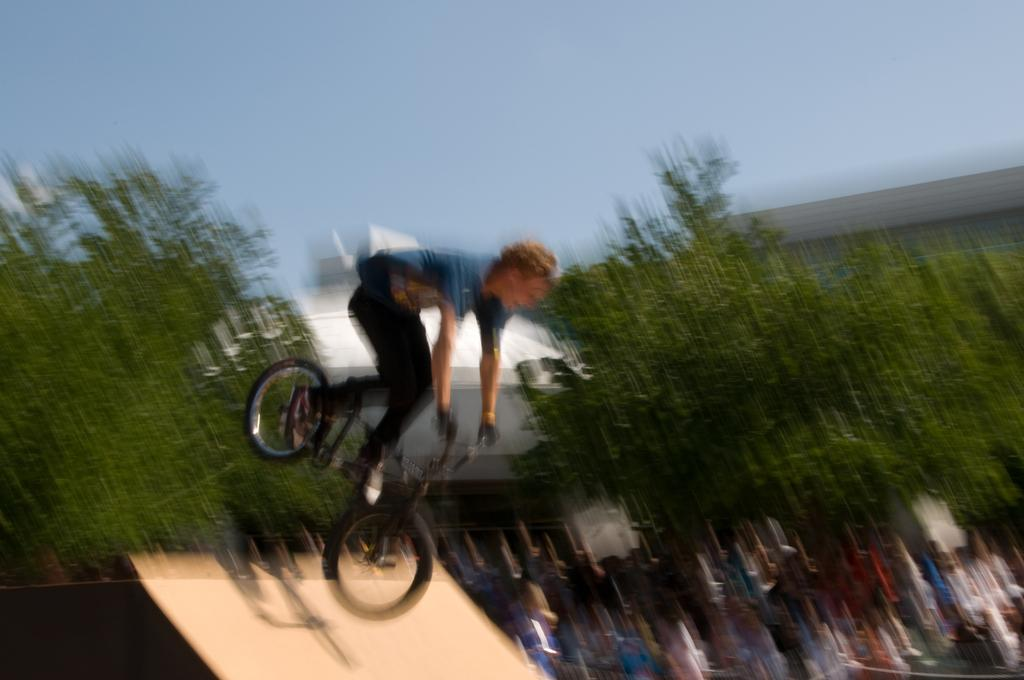What can be seen at the top of the image? The sky is visible at the top of the image. Can you describe the person in the image? There is a man in the image. What is the man doing in the image? The man is trying to slide on a board with a bicycle. How would you describe the clarity of the image? The bottom half of the image is blurry. Can you hear the deer crying in the image? There is no deer present in the image, and therefore no crying can be heard. 